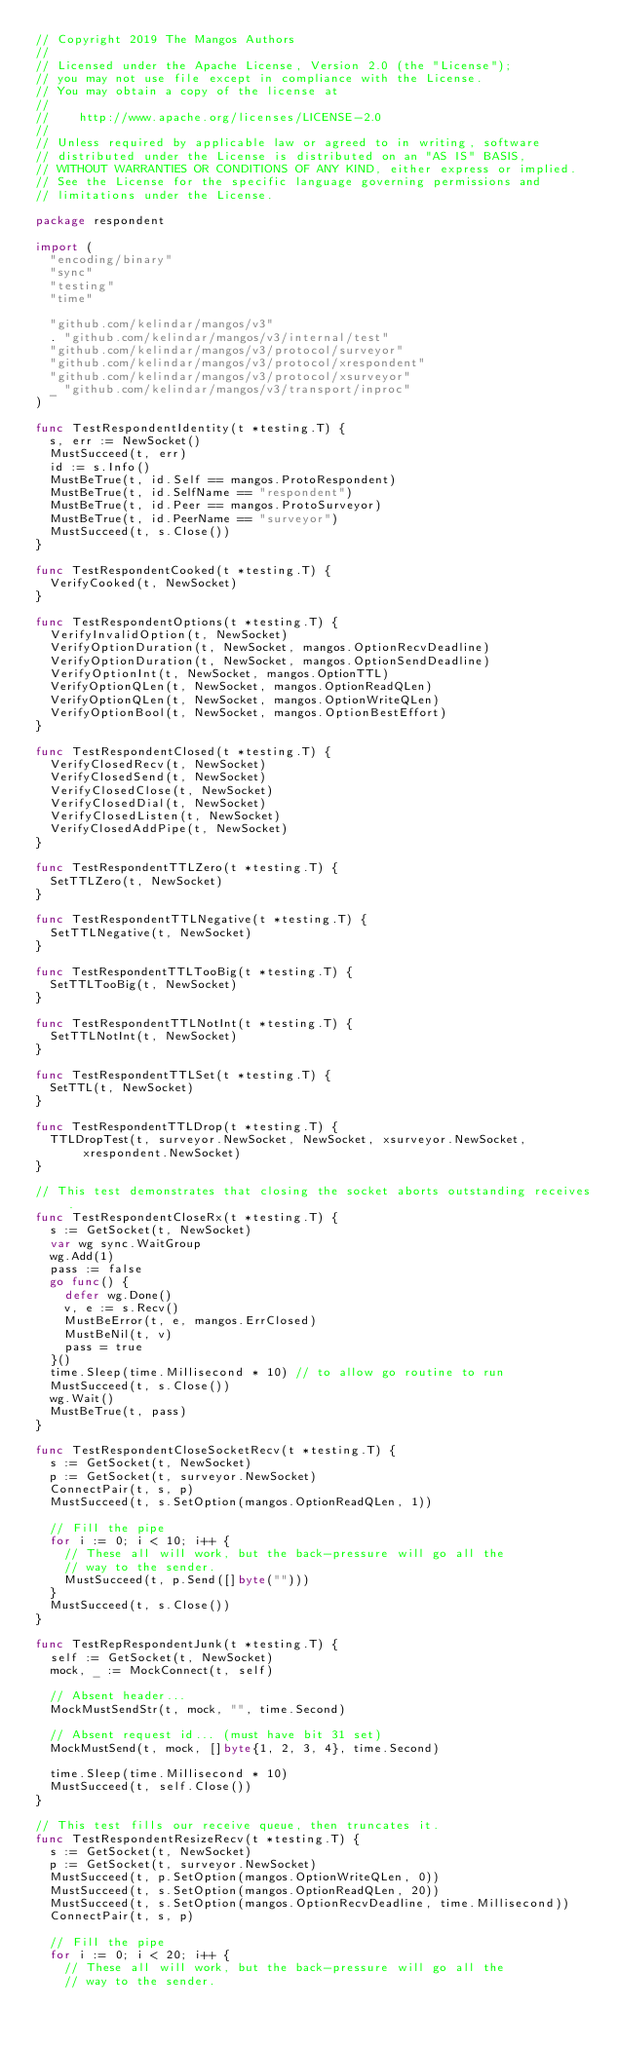<code> <loc_0><loc_0><loc_500><loc_500><_Go_>// Copyright 2019 The Mangos Authors
//
// Licensed under the Apache License, Version 2.0 (the "License");
// you may not use file except in compliance with the License.
// You may obtain a copy of the license at
//
//    http://www.apache.org/licenses/LICENSE-2.0
//
// Unless required by applicable law or agreed to in writing, software
// distributed under the License is distributed on an "AS IS" BASIS,
// WITHOUT WARRANTIES OR CONDITIONS OF ANY KIND, either express or implied.
// See the License for the specific language governing permissions and
// limitations under the License.

package respondent

import (
	"encoding/binary"
	"sync"
	"testing"
	"time"

	"github.com/kelindar/mangos/v3"
	. "github.com/kelindar/mangos/v3/internal/test"
	"github.com/kelindar/mangos/v3/protocol/surveyor"
	"github.com/kelindar/mangos/v3/protocol/xrespondent"
	"github.com/kelindar/mangos/v3/protocol/xsurveyor"
	_ "github.com/kelindar/mangos/v3/transport/inproc"
)

func TestRespondentIdentity(t *testing.T) {
	s, err := NewSocket()
	MustSucceed(t, err)
	id := s.Info()
	MustBeTrue(t, id.Self == mangos.ProtoRespondent)
	MustBeTrue(t, id.SelfName == "respondent")
	MustBeTrue(t, id.Peer == mangos.ProtoSurveyor)
	MustBeTrue(t, id.PeerName == "surveyor")
	MustSucceed(t, s.Close())
}

func TestRespondentCooked(t *testing.T) {
	VerifyCooked(t, NewSocket)
}

func TestRespondentOptions(t *testing.T) {
	VerifyInvalidOption(t, NewSocket)
	VerifyOptionDuration(t, NewSocket, mangos.OptionRecvDeadline)
	VerifyOptionDuration(t, NewSocket, mangos.OptionSendDeadline)
	VerifyOptionInt(t, NewSocket, mangos.OptionTTL)
	VerifyOptionQLen(t, NewSocket, mangos.OptionReadQLen)
	VerifyOptionQLen(t, NewSocket, mangos.OptionWriteQLen)
	VerifyOptionBool(t, NewSocket, mangos.OptionBestEffort)
}

func TestRespondentClosed(t *testing.T) {
	VerifyClosedRecv(t, NewSocket)
	VerifyClosedSend(t, NewSocket)
	VerifyClosedClose(t, NewSocket)
	VerifyClosedDial(t, NewSocket)
	VerifyClosedListen(t, NewSocket)
	VerifyClosedAddPipe(t, NewSocket)
}

func TestRespondentTTLZero(t *testing.T) {
	SetTTLZero(t, NewSocket)
}

func TestRespondentTTLNegative(t *testing.T) {
	SetTTLNegative(t, NewSocket)
}

func TestRespondentTTLTooBig(t *testing.T) {
	SetTTLTooBig(t, NewSocket)
}

func TestRespondentTTLNotInt(t *testing.T) {
	SetTTLNotInt(t, NewSocket)
}

func TestRespondentTTLSet(t *testing.T) {
	SetTTL(t, NewSocket)
}

func TestRespondentTTLDrop(t *testing.T) {
	TTLDropTest(t, surveyor.NewSocket, NewSocket, xsurveyor.NewSocket, xrespondent.NewSocket)
}

// This test demonstrates that closing the socket aborts outstanding receives.
func TestRespondentCloseRx(t *testing.T) {
	s := GetSocket(t, NewSocket)
	var wg sync.WaitGroup
	wg.Add(1)
	pass := false
	go func() {
		defer wg.Done()
		v, e := s.Recv()
		MustBeError(t, e, mangos.ErrClosed)
		MustBeNil(t, v)
		pass = true
	}()
	time.Sleep(time.Millisecond * 10) // to allow go routine to run
	MustSucceed(t, s.Close())
	wg.Wait()
	MustBeTrue(t, pass)
}

func TestRespondentCloseSocketRecv(t *testing.T) {
	s := GetSocket(t, NewSocket)
	p := GetSocket(t, surveyor.NewSocket)
	ConnectPair(t, s, p)
	MustSucceed(t, s.SetOption(mangos.OptionReadQLen, 1))

	// Fill the pipe
	for i := 0; i < 10; i++ {
		// These all will work, but the back-pressure will go all the
		// way to the sender.
		MustSucceed(t, p.Send([]byte("")))
	}
	MustSucceed(t, s.Close())
}

func TestRepRespondentJunk(t *testing.T) {
	self := GetSocket(t, NewSocket)
	mock, _ := MockConnect(t, self)

	// Absent header...
	MockMustSendStr(t, mock, "", time.Second)

	// Absent request id... (must have bit 31 set)
	MockMustSend(t, mock, []byte{1, 2, 3, 4}, time.Second)

	time.Sleep(time.Millisecond * 10)
	MustSucceed(t, self.Close())
}

// This test fills our receive queue, then truncates it.
func TestRespondentResizeRecv(t *testing.T) {
	s := GetSocket(t, NewSocket)
	p := GetSocket(t, surveyor.NewSocket)
	MustSucceed(t, p.SetOption(mangos.OptionWriteQLen, 0))
	MustSucceed(t, s.SetOption(mangos.OptionReadQLen, 20))
	MustSucceed(t, s.SetOption(mangos.OptionRecvDeadline, time.Millisecond))
	ConnectPair(t, s, p)

	// Fill the pipe
	for i := 0; i < 20; i++ {
		// These all will work, but the back-pressure will go all the
		// way to the sender.</code> 